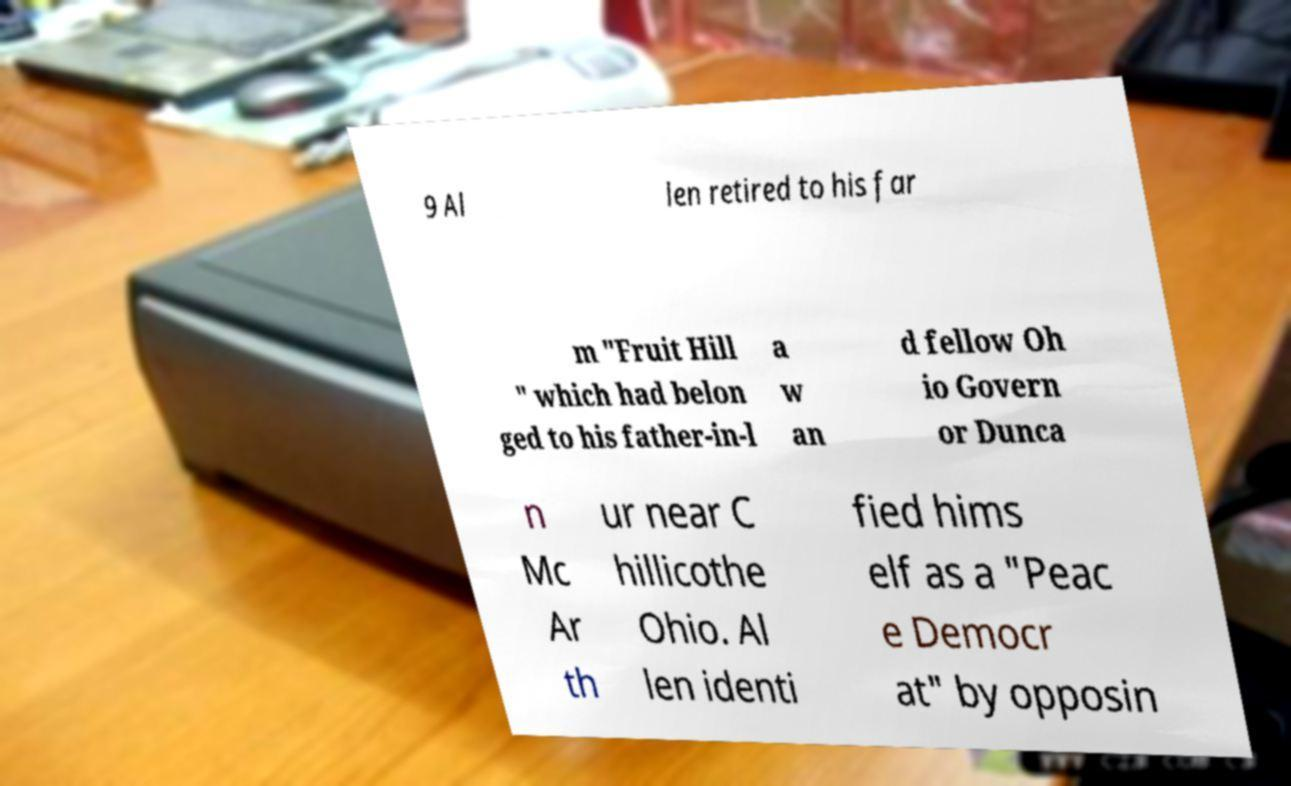There's text embedded in this image that I need extracted. Can you transcribe it verbatim? 9 Al len retired to his far m "Fruit Hill " which had belon ged to his father-in-l a w an d fellow Oh io Govern or Dunca n Mc Ar th ur near C hillicothe Ohio. Al len identi fied hims elf as a "Peac e Democr at" by opposin 